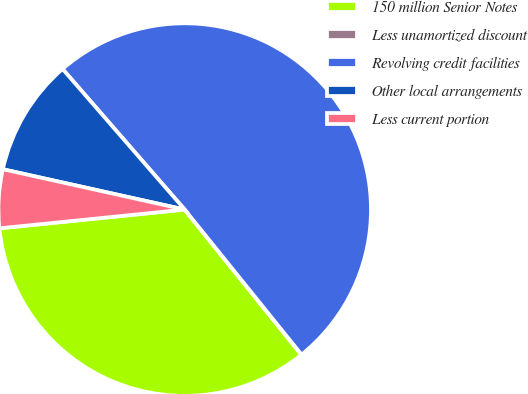Convert chart to OTSL. <chart><loc_0><loc_0><loc_500><loc_500><pie_chart><fcel>150 million Senior Notes<fcel>Less unamortized discount<fcel>Revolving credit facilities<fcel>Other local arrangements<fcel>Less current portion<nl><fcel>34.17%<fcel>0.02%<fcel>50.59%<fcel>10.14%<fcel>5.08%<nl></chart> 